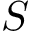Convert formula to latex. <formula><loc_0><loc_0><loc_500><loc_500>S</formula> 